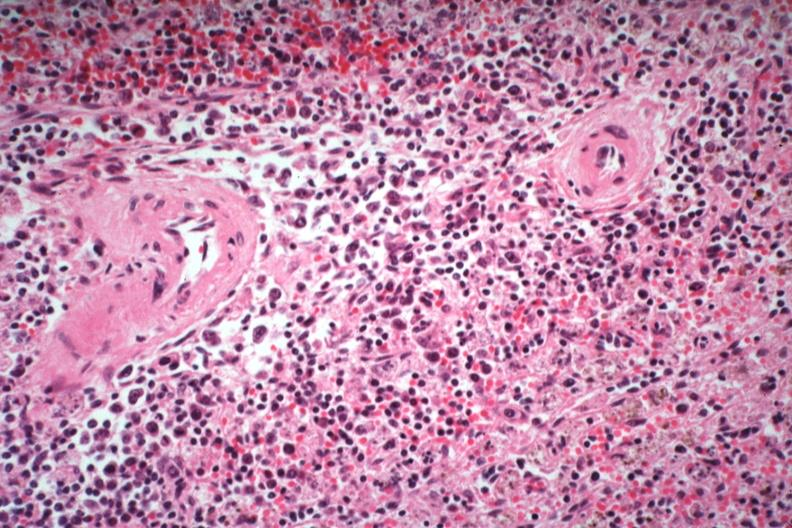what is present?
Answer the question using a single word or phrase. Spleen 